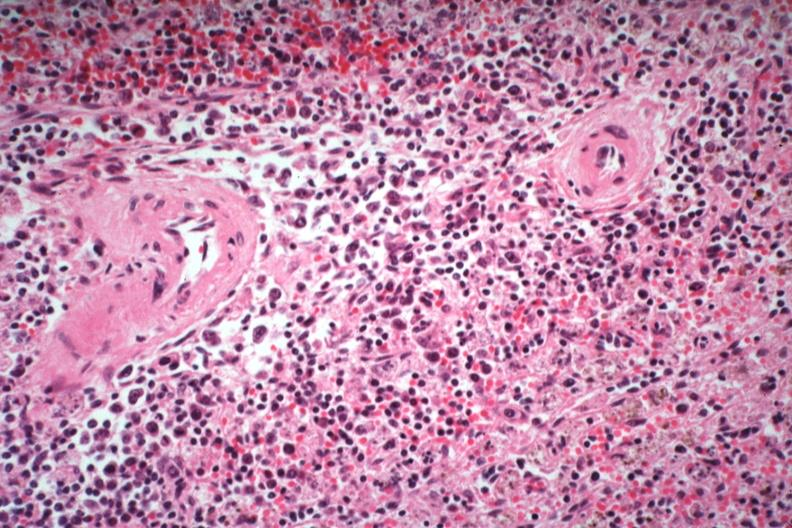what is present?
Answer the question using a single word or phrase. Spleen 